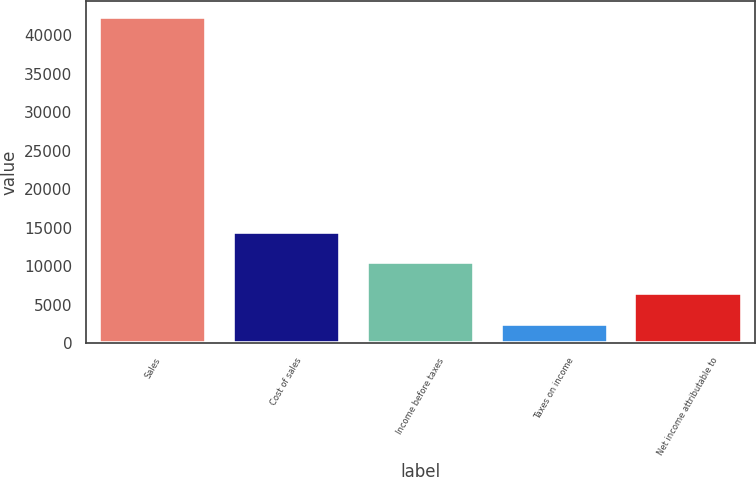Convert chart to OTSL. <chart><loc_0><loc_0><loc_500><loc_500><bar_chart><fcel>Sales<fcel>Cost of sales<fcel>Income before taxes<fcel>Taxes on income<fcel>Net income attributable to<nl><fcel>42294<fcel>14443.8<fcel>10465.2<fcel>2508<fcel>6486.6<nl></chart> 